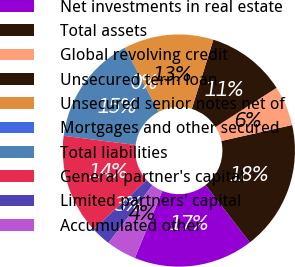Convert chart. <chart><loc_0><loc_0><loc_500><loc_500><pie_chart><fcel>Net investments in real estate<fcel>Total assets<fcel>Global revolving credit<fcel>Unsecured term loan<fcel>Unsecured senior notes net of<fcel>Mortgages and other secured<fcel>Total liabilities<fcel>General partner's capital<fcel>Limited partners' capital<fcel>Accumulated other<nl><fcel>16.66%<fcel>18.05%<fcel>5.56%<fcel>11.11%<fcel>12.5%<fcel>0.0%<fcel>15.28%<fcel>13.89%<fcel>2.78%<fcel>4.17%<nl></chart> 